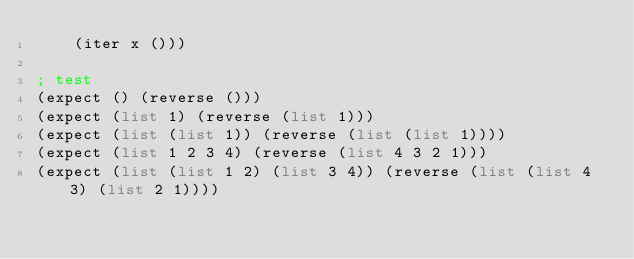<code> <loc_0><loc_0><loc_500><loc_500><_Scheme_>    (iter x ()))

; test
(expect () (reverse ()))
(expect (list 1) (reverse (list 1)))
(expect (list (list 1)) (reverse (list (list 1))))
(expect (list 1 2 3 4) (reverse (list 4 3 2 1)))
(expect (list (list 1 2) (list 3 4)) (reverse (list (list 4 3) (list 2 1))))

</code> 